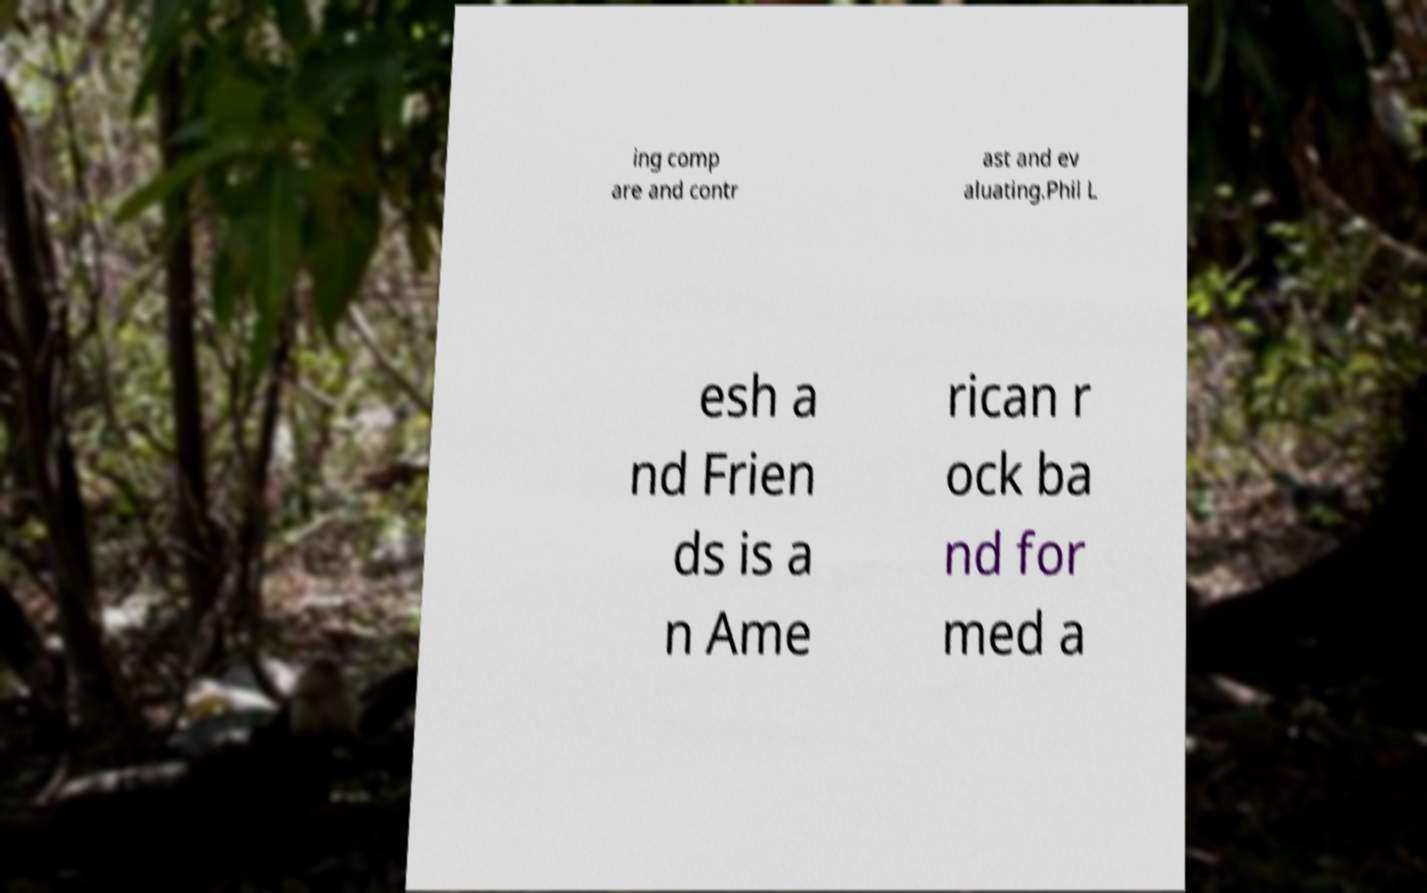Please read and relay the text visible in this image. What does it say? ing comp are and contr ast and ev aluating.Phil L esh a nd Frien ds is a n Ame rican r ock ba nd for med a 